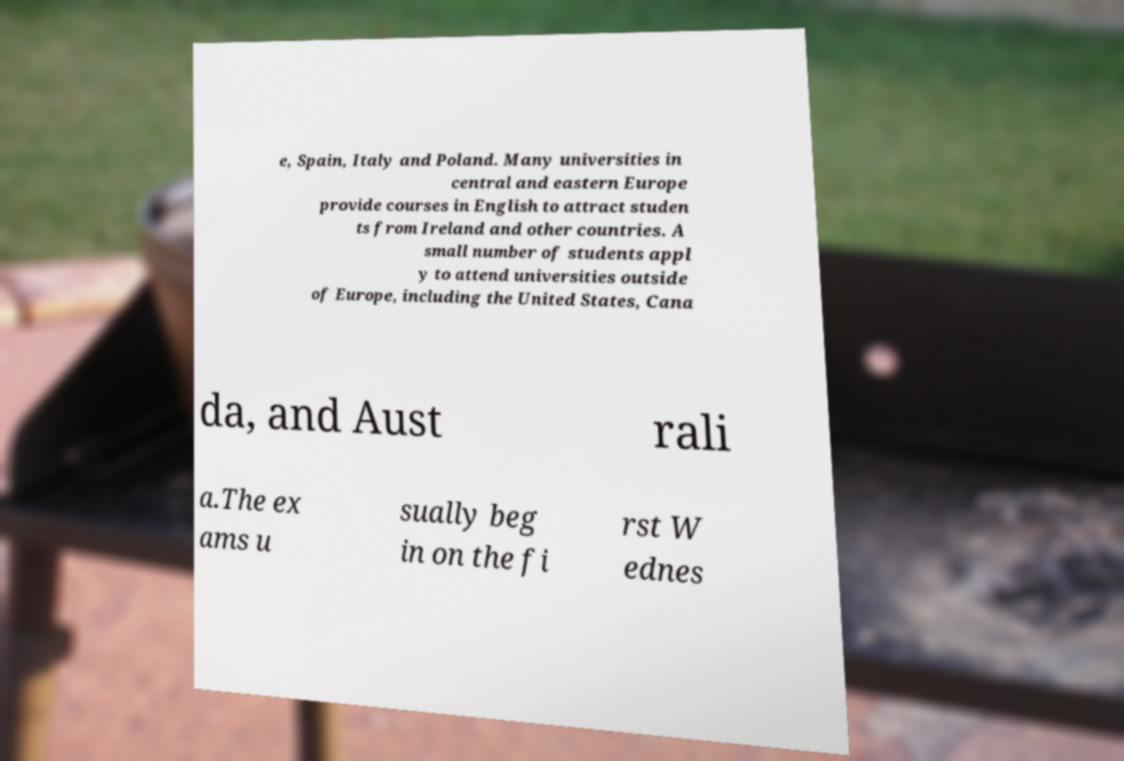What messages or text are displayed in this image? I need them in a readable, typed format. e, Spain, Italy and Poland. Many universities in central and eastern Europe provide courses in English to attract studen ts from Ireland and other countries. A small number of students appl y to attend universities outside of Europe, including the United States, Cana da, and Aust rali a.The ex ams u sually beg in on the fi rst W ednes 